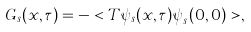Convert formula to latex. <formula><loc_0><loc_0><loc_500><loc_500>G _ { s } ( x , \tau ) = - < T \psi _ { s } ( x , \tau ) \psi _ { s } ^ { \dagger } ( 0 , 0 ) > ,</formula> 